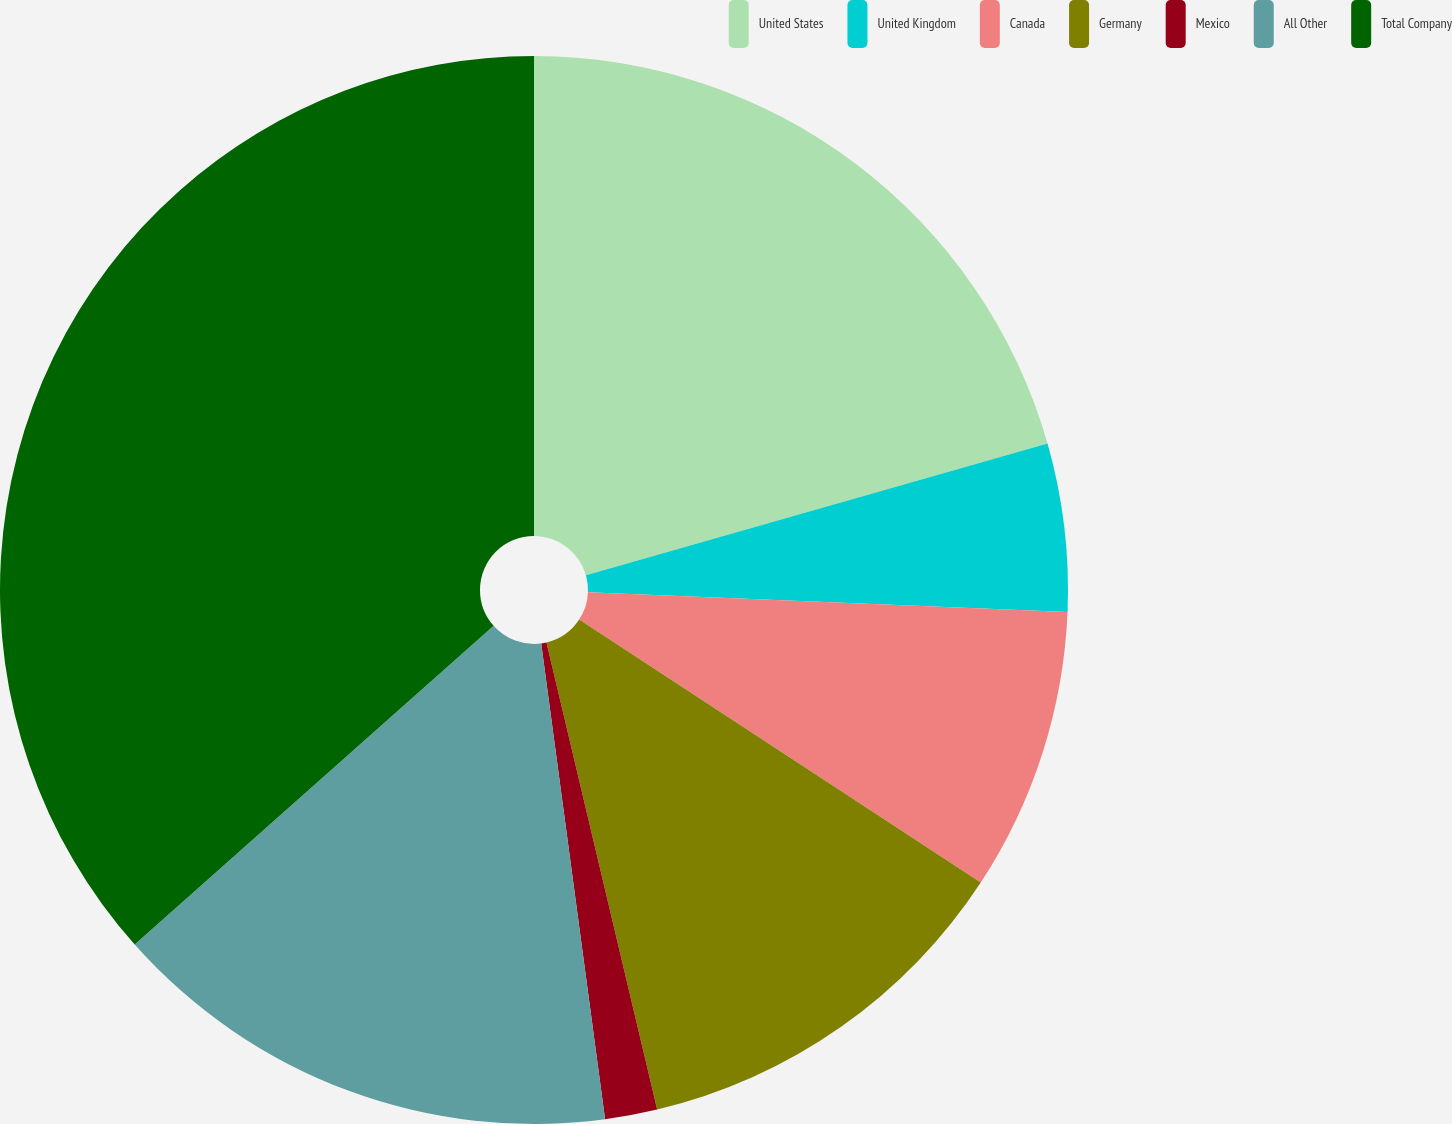Convert chart to OTSL. <chart><loc_0><loc_0><loc_500><loc_500><pie_chart><fcel>United States<fcel>United Kingdom<fcel>Canada<fcel>Germany<fcel>Mexico<fcel>All Other<fcel>Total Company<nl><fcel>20.58%<fcel>5.08%<fcel>8.57%<fcel>12.07%<fcel>1.58%<fcel>15.57%<fcel>36.56%<nl></chart> 